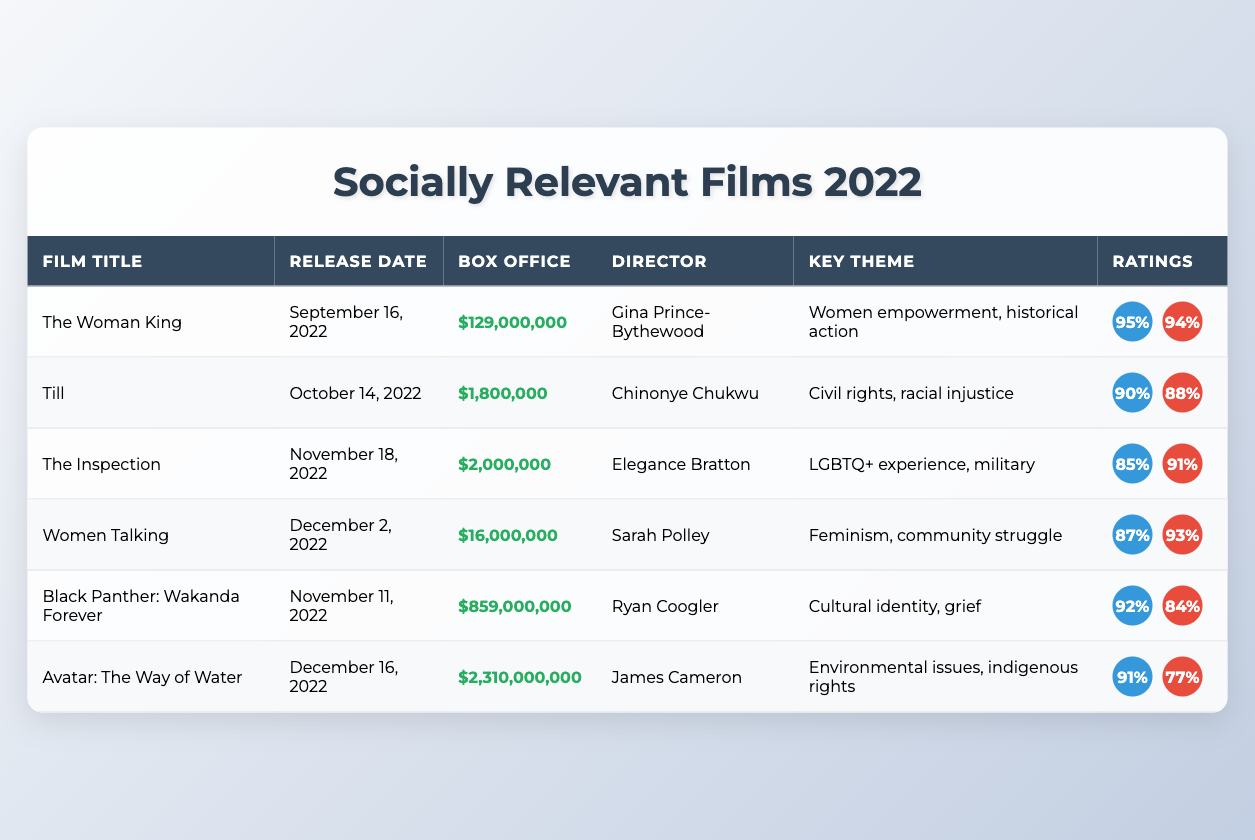What is the box office gross of "The Woman King"? The box office gross for "The Woman King" is stated directly in the table as $129,000,000.
Answer: $129,000,000 Which film had the highest box office gross in 2022? Looking at the box office gross figures listed in the table, "Avatar: The Way of Water" has the highest gross of $2,310,000,000.
Answer: "Avatar: The Way of Water" How many films total had an audience rating above 90%? By inspecting the audience ratings, "The Woman King," "Till," "Black Panther: Wakanda Forever," and "Avatar: The Way of Water" all exceed 90%. This makes a total of four films.
Answer: 4 What is the average critics rating for the films listed? To find the average critics rating, add the ratings (94 + 88 + 91 + 93 + 84 + 77 = 527) and divide by the number of films (6): 527 / 6 = 87.83.
Answer: 87.83 Did "Women Talking" earn more than "The Inspection"? Comparing the box office gross values in the table, "Women Talking" grossed $16,000,000, while "The Inspection" grossed $2,000,000. Since $16,000,000 is greater than $2,000,000, the answer is yes.
Answer: Yes What is the key theme of "Black Panther: Wakanda Forever"? The key theme for "Black Panther: Wakanda Forever" is stated in the table as "Cultural identity, grief."
Answer: Cultural identity, grief Calculate the difference in box office gross between "Avatar: The Way of Water" and "The Woman King". "Avatar: The Way of Water" grossed $2,310,000,000 and "The Woman King" grossed $129,000,000. The difference is $2,310,000,000 - $129,000,000 = $2,180,000,000.
Answer: $2,180,000,000 How many films were directed by women? Counting the directors, "The Woman King," "Till," "The Inspection," and "Women Talking" were directed by women, totaling four films.
Answer: 4 Is the average audience rating for all films lower than 90%? The average audience rating is calculated as (95 + 90 + 85 + 87 + 92 + 91 = 540) divided by 6, which is 90. Hence, the answer is no; it's not lower than 90%.
Answer: No Which film has the lowest box office gross? In the box office gross column, "Till" shows the lowest with a gross of $1,800,000.
Answer: "Till" 